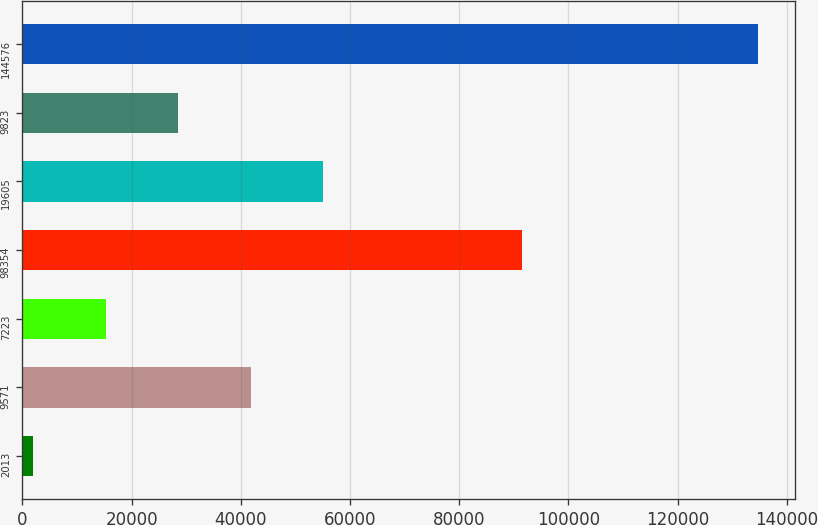<chart> <loc_0><loc_0><loc_500><loc_500><bar_chart><fcel>2013<fcel>9571<fcel>7223<fcel>98354<fcel>19605<fcel>9823<fcel>144576<nl><fcel>2012<fcel>41827.1<fcel>15283.7<fcel>91587<fcel>55098.8<fcel>28555.4<fcel>134729<nl></chart> 